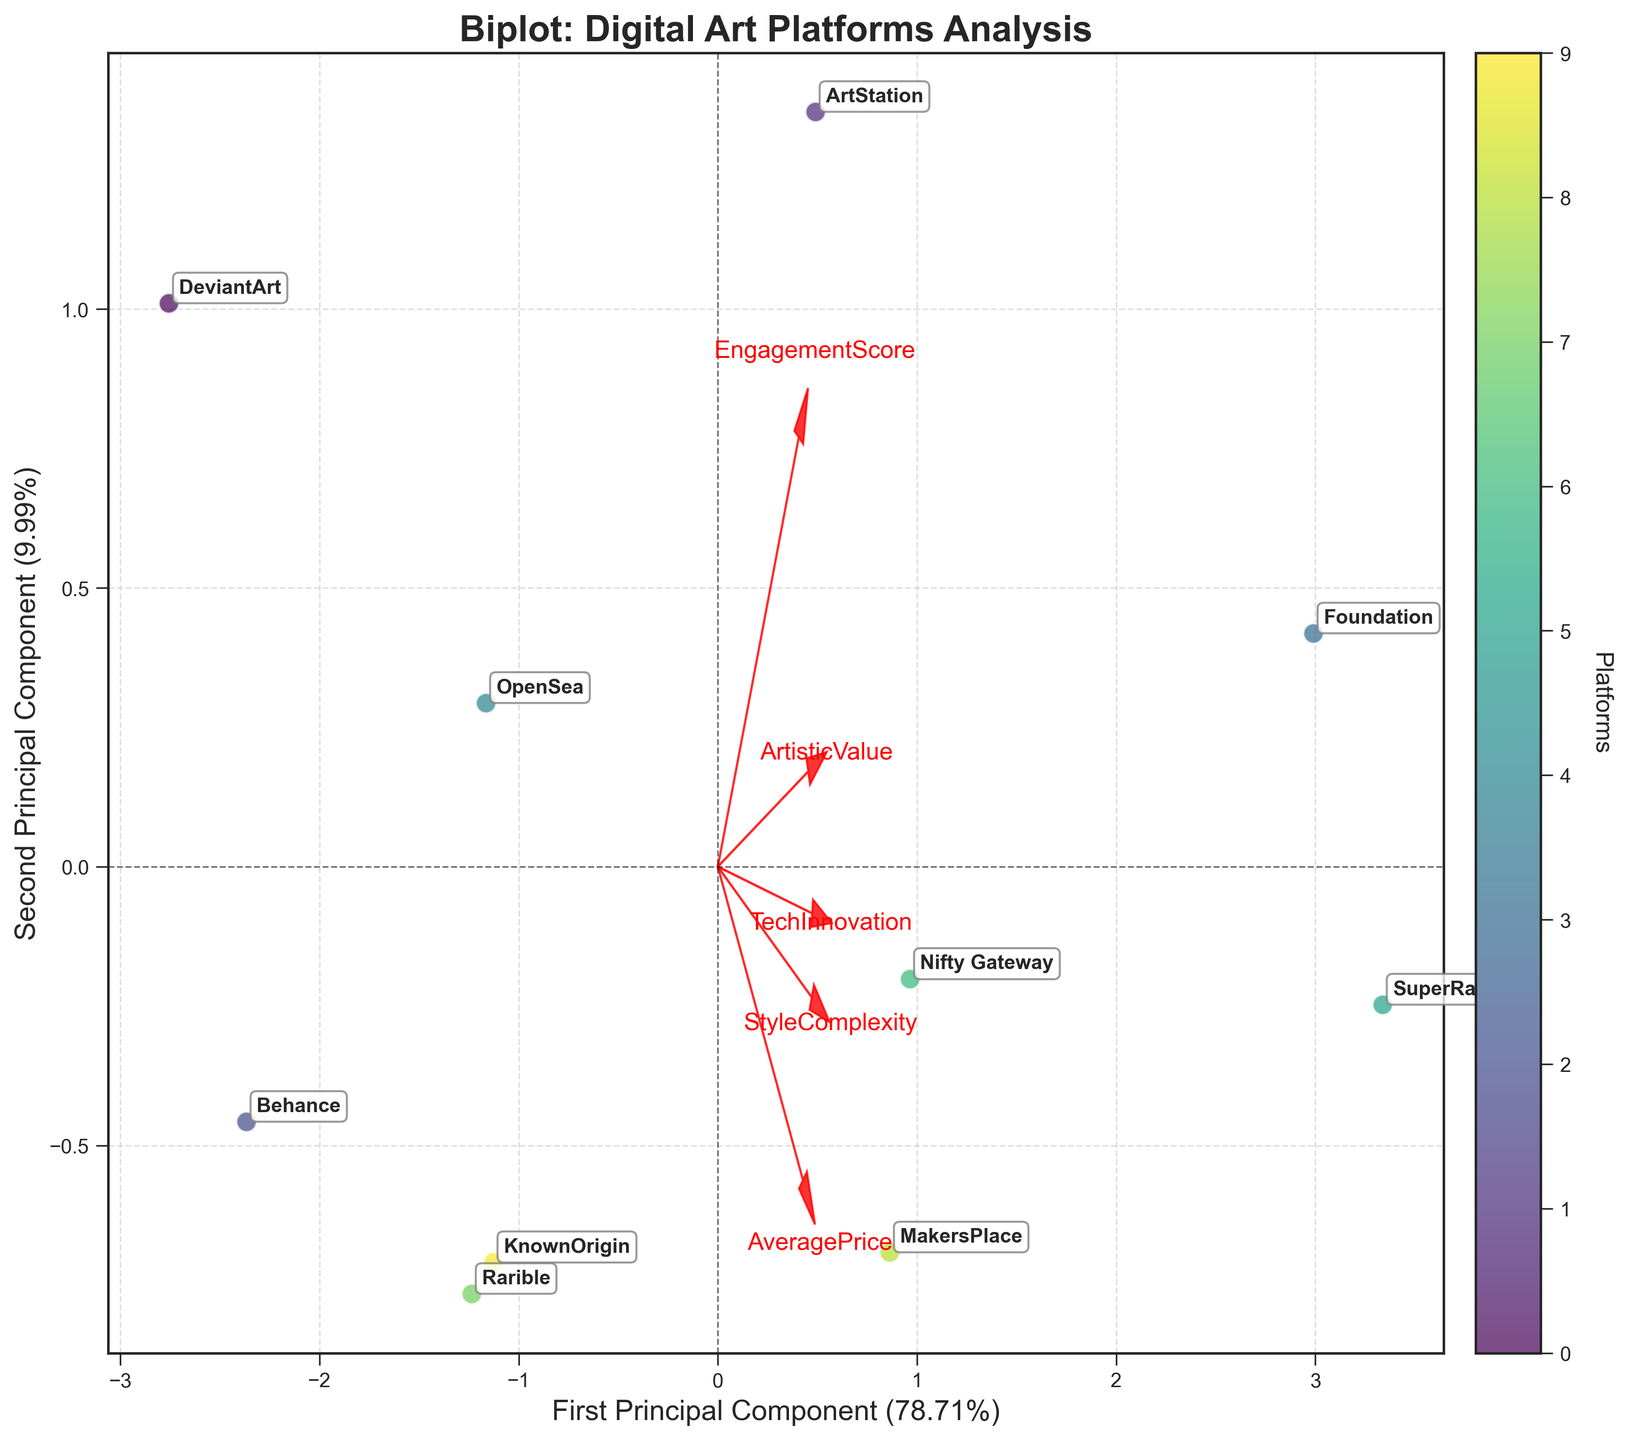How many data points are plotted in the biplot? To determine the number of data points, we count the number of labeled points on the plot. Each point represents a different platform from the provided data.
Answer: 10 Which platform appears to have the highest EngagementScore? By inspecting the plot and looking at the location of the platforms, we see that ArtStation is positioned far to the right, which indicates a higher EngagementScore among the platforms.
Answer: ArtStation Which two features (variables) have the strongest relationship based on the direction of their vectors in the biplot? In a biplot, features (variables) that have vectors pointing in the same or similar direction indicate a strong relationship. Observing the vectors, 'TechInnovation' and 'ArtisticValue' are closely aligned, suggesting a strong relationship.
Answer: TechInnovation and ArtisticValue How does the average price of the artworks affect the positions of the platforms in the biplot? Platforms with higher average prices are likely positioned further along one or both principal components. Reviewing their positions, platforms like SuperRare and Foundation are seen further along, indicating higher average prices.
Answer: Higher average prices push platforms further along principal components Compare "ArtStation" and "SuperRare" in terms of their PCA coordinates. Which platform is more tech-innovative? By examining the biplot, we observe the respective coordinates of ArtStation and SuperRare. SuperRare is positioned further in the direction of the 'TechInnovation' vector, indicating it is more tech-innovative compared to ArtStation.
Answer: SuperRare What can we say about the engagement score and artistic value of "KnownOrigin" compared to "Foundation"? Evaluating the positions of KnownOrigin and Foundation relative to the engagement score and artistic value vectors, Foundation is positioned further along these vectors, indicating it has both a higher engagement score and artistic value compared to KnownOrigin.
Answer: Foundation has higher engagement score and artistic value Which platform is positioned closest to the origin of the biplot? Observing the plot, the platform directly closest to the origin, where the principal components intersect, is "Behance".
Answer: Behance Does "OpenSea" exhibit higher StyleComplexity or higher ArtisticValue? To determine this, we look at the position of OpenSea in relation to the crossing vectors for StyleComplexity and ArtisticValue. OpenSea is closer to the ArtisticValue vector, indicating it has a higher ArtisticValue than StyleComplexity.
Answer: Higher ArtisticValue What can be inferred about the relationship between EngagementScore and AveragePrice from the plot? Observing the vectors for EngagementScore and AveragePrice, we see they are not closely aligned and are positioned at angles to each other. This suggests a weaker or non-linear relationship between these two features.
Answer: Weak or non-linear relationship 